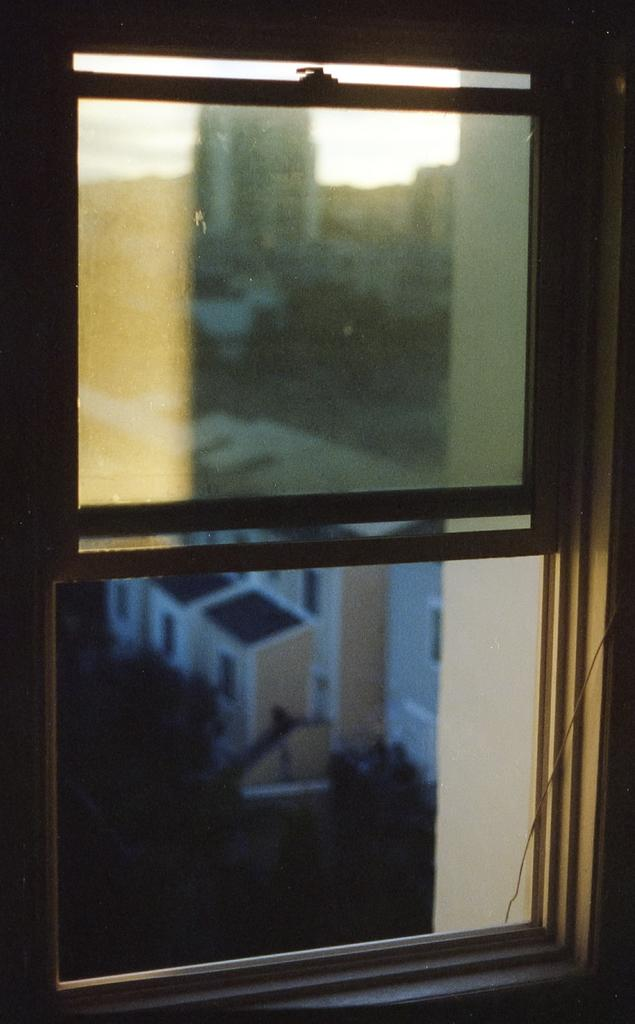What is located in the foreground area of the image? There is a window in the foreground area of the image. What can be seen through the window? Buildings, the sky, and trees are visible outside the window. Is there any transportation visible outside the window? Yes, a vehicle is visible outside the window. Can you see the arm of the person touching the building outside the window? There is no person or arm visible in the image; it only shows a window with buildings, the sky, trees, and a vehicle outside. 